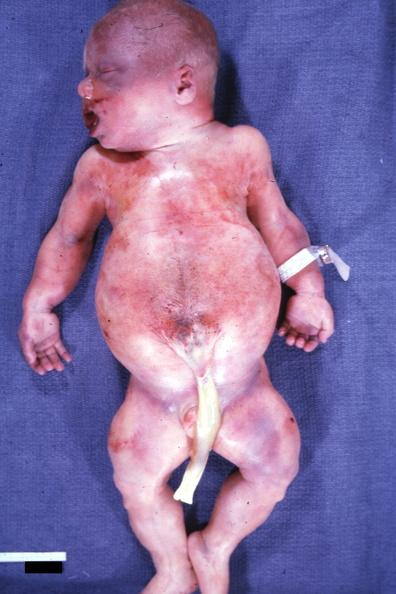what are this whole body photo showing widened abdomen due to diastasis recti and crease in ear lobe face is slide and kidneys with bilateral pelvic-ureteral strictures?
Answer the question using a single word or phrase. Strictures 